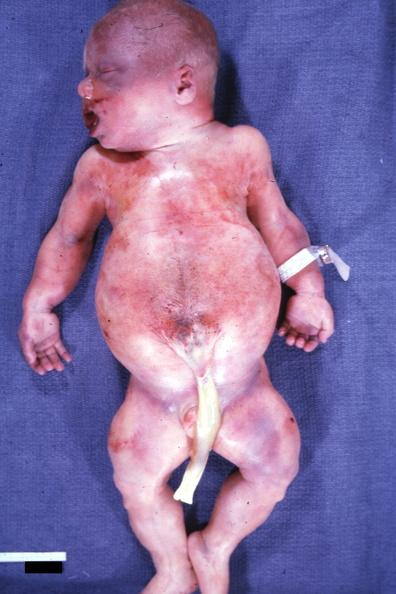what are this whole body photo showing widened abdomen due to diastasis recti and crease in ear lobe face is slide and kidneys with bilateral pelvic-ureteral strictures?
Answer the question using a single word or phrase. Strictures 